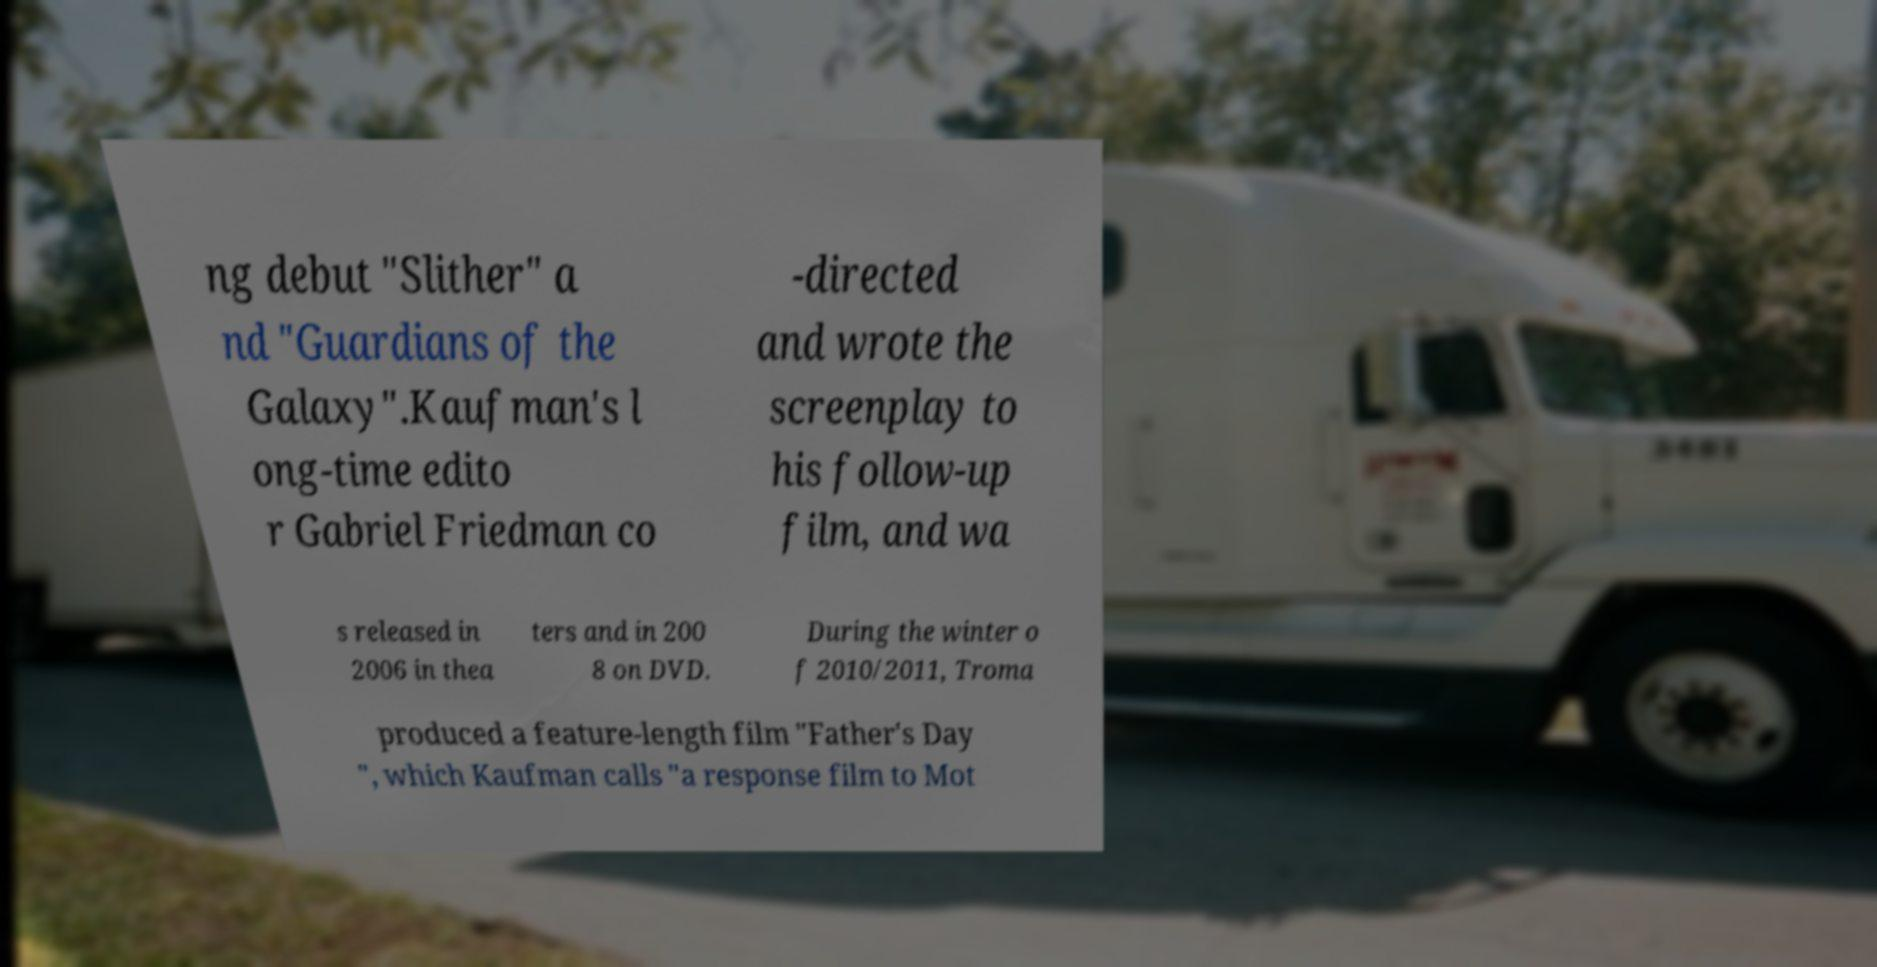Could you assist in decoding the text presented in this image and type it out clearly? ng debut "Slither" a nd "Guardians of the Galaxy".Kaufman's l ong-time edito r Gabriel Friedman co -directed and wrote the screenplay to his follow-up film, and wa s released in 2006 in thea ters and in 200 8 on DVD. During the winter o f 2010/2011, Troma produced a feature-length film "Father's Day ", which Kaufman calls "a response film to Mot 